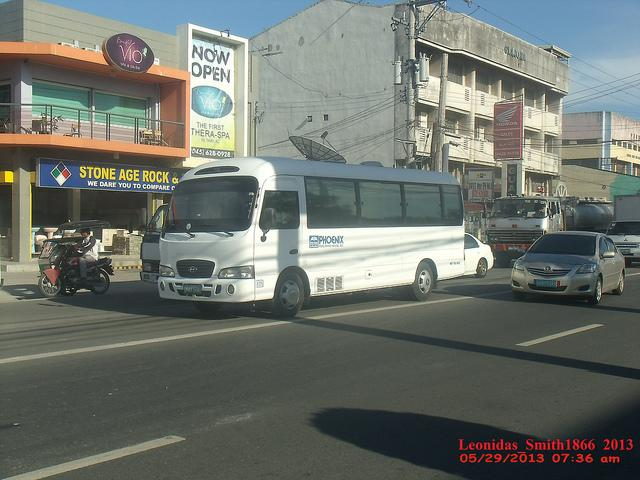What type of vehicle is sold in the building to the rear of the bus?

Choices:
A) cars
B) motorcycles
C) tractors
D) trucks motorcycles 